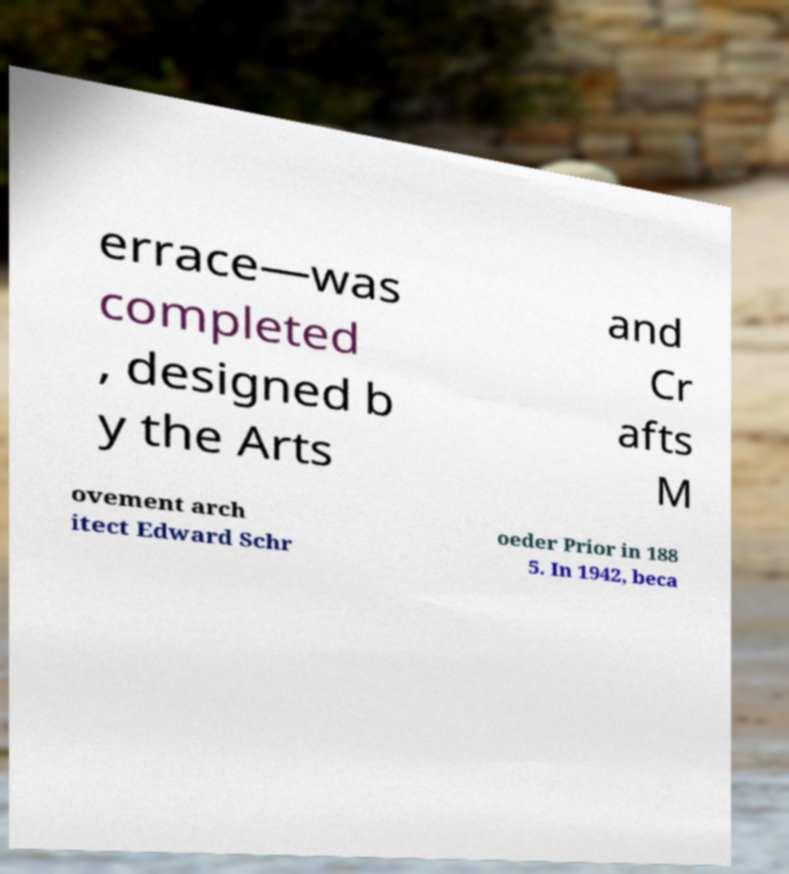Please identify and transcribe the text found in this image. errace—was completed , designed b y the Arts and Cr afts M ovement arch itect Edward Schr oeder Prior in 188 5. In 1942, beca 